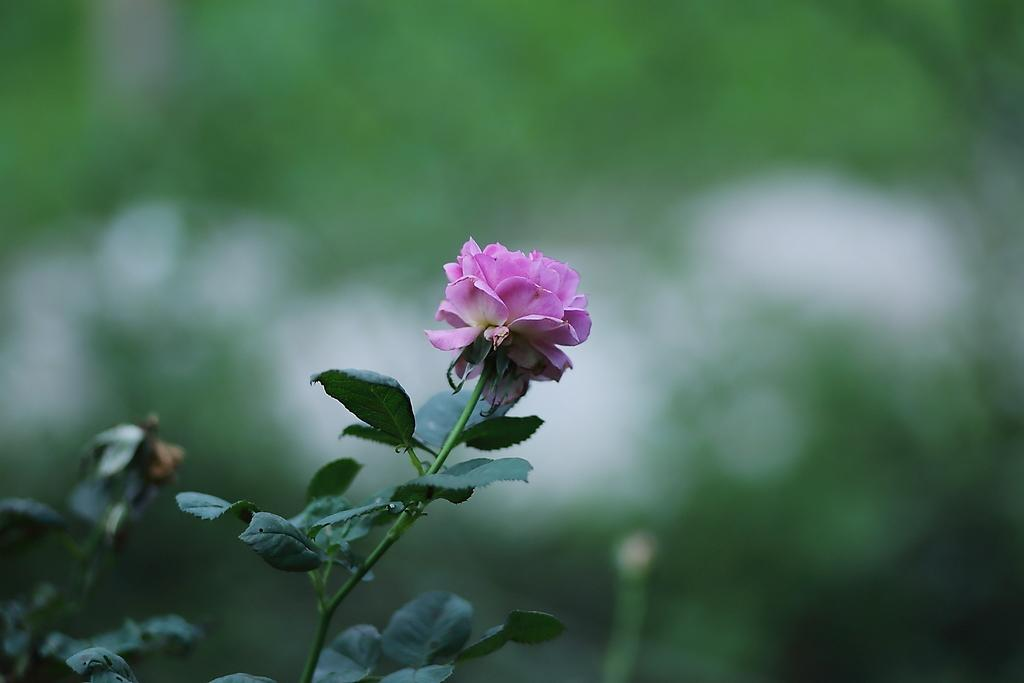What type of living organism can be seen in the image? There is a plant in the image. What specific part of the plant is visible? There is a flower in the image. How would you describe the background of the image? The background of the image is blurred. What type of trousers can be seen hanging on the plant in the image? There are no trousers present in the image; it features a plant with a flower. What type of grain is visible growing on the plant in the image? There is no grain present in the image; it features a plant with a flower. 